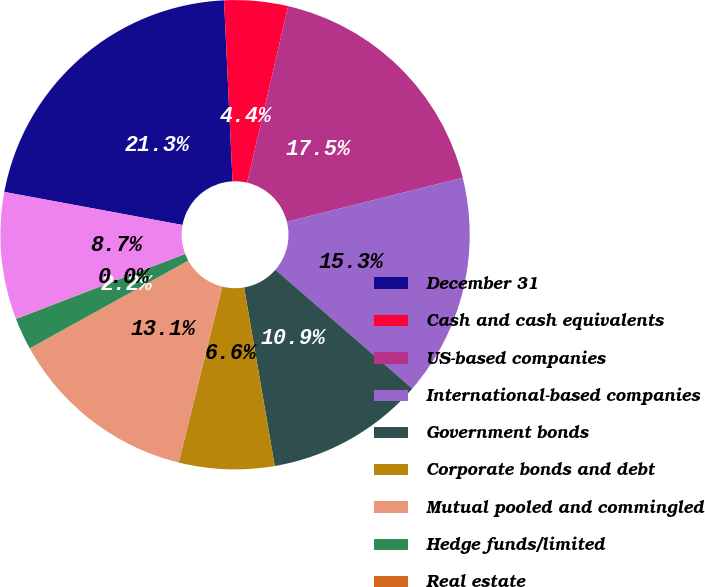Convert chart to OTSL. <chart><loc_0><loc_0><loc_500><loc_500><pie_chart><fcel>December 31<fcel>Cash and cash equivalents<fcel>US-based companies<fcel>International-based companies<fcel>Government bonds<fcel>Corporate bonds and debt<fcel>Mutual pooled and commingled<fcel>Hedge funds/limited<fcel>Real estate<fcel>Other<nl><fcel>21.33%<fcel>4.38%<fcel>17.46%<fcel>15.28%<fcel>10.92%<fcel>6.56%<fcel>13.1%<fcel>2.2%<fcel>0.02%<fcel>8.74%<nl></chart> 